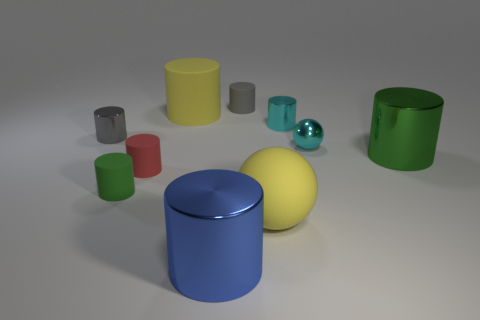Subtract 3 cylinders. How many cylinders are left? 5 Subtract all gray cylinders. How many cylinders are left? 6 Subtract all red matte cylinders. How many cylinders are left? 7 Subtract all brown cylinders. Subtract all purple balls. How many cylinders are left? 8 Subtract all spheres. How many objects are left? 8 Subtract all big green metallic cylinders. Subtract all yellow spheres. How many objects are left? 8 Add 3 cyan shiny spheres. How many cyan shiny spheres are left? 4 Add 8 small cyan matte spheres. How many small cyan matte spheres exist? 8 Subtract 0 cyan cubes. How many objects are left? 10 